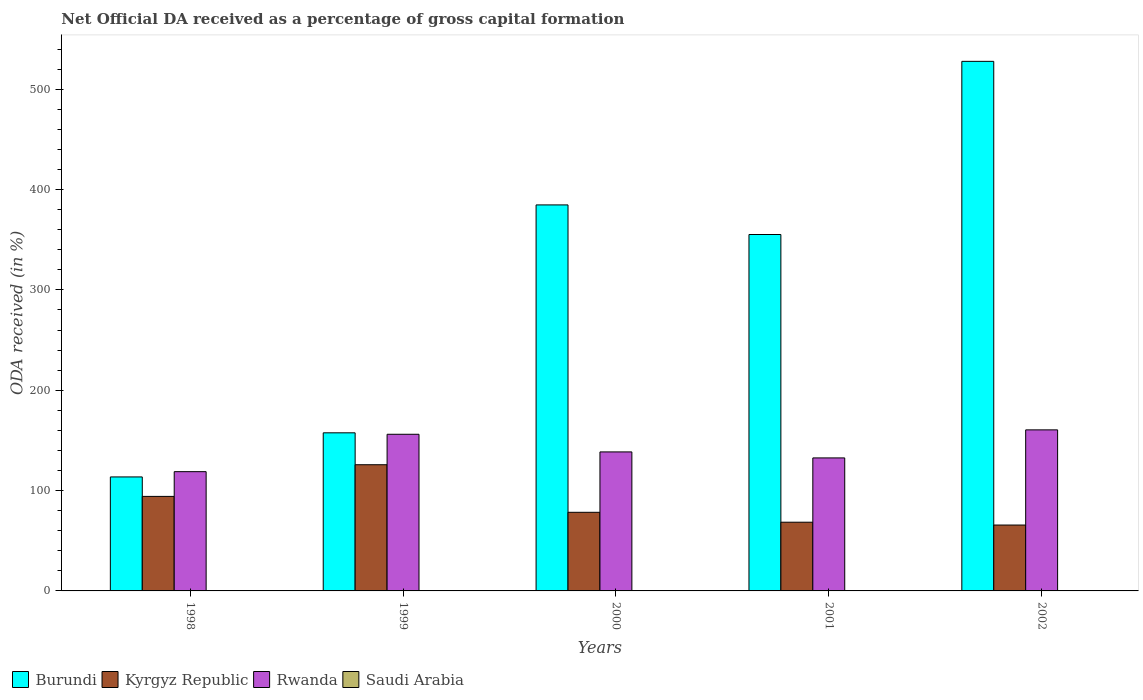Are the number of bars per tick equal to the number of legend labels?
Your answer should be very brief. Yes. How many bars are there on the 2nd tick from the right?
Your answer should be very brief. 4. What is the net ODA received in Kyrgyz Republic in 2000?
Make the answer very short. 78.34. Across all years, what is the maximum net ODA received in Burundi?
Your response must be concise. 527.71. Across all years, what is the minimum net ODA received in Kyrgyz Republic?
Ensure brevity in your answer.  65.66. What is the total net ODA received in Rwanda in the graph?
Give a very brief answer. 706.49. What is the difference between the net ODA received in Burundi in 1998 and that in 2000?
Ensure brevity in your answer.  -271.05. What is the difference between the net ODA received in Saudi Arabia in 2000 and the net ODA received in Rwanda in 2002?
Your response must be concise. -160.42. What is the average net ODA received in Kyrgyz Republic per year?
Your response must be concise. 86.48. In the year 2002, what is the difference between the net ODA received in Rwanda and net ODA received in Kyrgyz Republic?
Offer a very short reply. 94.83. In how many years, is the net ODA received in Burundi greater than 200 %?
Offer a terse response. 3. What is the ratio of the net ODA received in Burundi in 1998 to that in 2001?
Your response must be concise. 0.32. Is the net ODA received in Rwanda in 2000 less than that in 2001?
Your answer should be very brief. No. What is the difference between the highest and the second highest net ODA received in Saudi Arabia?
Your response must be concise. 0. What is the difference between the highest and the lowest net ODA received in Kyrgyz Republic?
Give a very brief answer. 60.09. In how many years, is the net ODA received in Saudi Arabia greater than the average net ODA received in Saudi Arabia taken over all years?
Offer a very short reply. 2. Is it the case that in every year, the sum of the net ODA received in Saudi Arabia and net ODA received in Rwanda is greater than the sum of net ODA received in Burundi and net ODA received in Kyrgyz Republic?
Keep it short and to the point. No. What does the 3rd bar from the left in 1999 represents?
Offer a terse response. Rwanda. What does the 2nd bar from the right in 1999 represents?
Your answer should be very brief. Rwanda. How many years are there in the graph?
Make the answer very short. 5. What is the title of the graph?
Your response must be concise. Net Official DA received as a percentage of gross capital formation. What is the label or title of the X-axis?
Provide a succinct answer. Years. What is the label or title of the Y-axis?
Offer a very short reply. ODA received (in %). What is the ODA received (in %) in Burundi in 1998?
Give a very brief answer. 113.59. What is the ODA received (in %) of Kyrgyz Republic in 1998?
Keep it short and to the point. 94.2. What is the ODA received (in %) in Rwanda in 1998?
Offer a very short reply. 118.84. What is the ODA received (in %) of Saudi Arabia in 1998?
Keep it short and to the point. 0.05. What is the ODA received (in %) of Burundi in 1999?
Your answer should be compact. 157.54. What is the ODA received (in %) in Kyrgyz Republic in 1999?
Ensure brevity in your answer.  125.75. What is the ODA received (in %) in Rwanda in 1999?
Offer a terse response. 156.1. What is the ODA received (in %) in Saudi Arabia in 1999?
Ensure brevity in your answer.  0.07. What is the ODA received (in %) in Burundi in 2000?
Give a very brief answer. 384.64. What is the ODA received (in %) in Kyrgyz Republic in 2000?
Provide a short and direct response. 78.34. What is the ODA received (in %) in Rwanda in 2000?
Provide a succinct answer. 138.52. What is the ODA received (in %) of Saudi Arabia in 2000?
Provide a succinct answer. 0.06. What is the ODA received (in %) of Burundi in 2001?
Your answer should be very brief. 355.15. What is the ODA received (in %) in Kyrgyz Republic in 2001?
Keep it short and to the point. 68.46. What is the ODA received (in %) in Rwanda in 2001?
Provide a short and direct response. 132.54. What is the ODA received (in %) in Saudi Arabia in 2001?
Your answer should be compact. 0.04. What is the ODA received (in %) of Burundi in 2002?
Provide a succinct answer. 527.71. What is the ODA received (in %) of Kyrgyz Republic in 2002?
Your answer should be compact. 65.66. What is the ODA received (in %) of Rwanda in 2002?
Your response must be concise. 160.48. What is the ODA received (in %) in Saudi Arabia in 2002?
Ensure brevity in your answer.  0.05. Across all years, what is the maximum ODA received (in %) of Burundi?
Make the answer very short. 527.71. Across all years, what is the maximum ODA received (in %) of Kyrgyz Republic?
Provide a succinct answer. 125.75. Across all years, what is the maximum ODA received (in %) in Rwanda?
Provide a short and direct response. 160.48. Across all years, what is the maximum ODA received (in %) in Saudi Arabia?
Ensure brevity in your answer.  0.07. Across all years, what is the minimum ODA received (in %) of Burundi?
Provide a short and direct response. 113.59. Across all years, what is the minimum ODA received (in %) of Kyrgyz Republic?
Your answer should be very brief. 65.66. Across all years, what is the minimum ODA received (in %) in Rwanda?
Your answer should be compact. 118.84. Across all years, what is the minimum ODA received (in %) of Saudi Arabia?
Your answer should be very brief. 0.04. What is the total ODA received (in %) of Burundi in the graph?
Your answer should be very brief. 1538.64. What is the total ODA received (in %) of Kyrgyz Republic in the graph?
Keep it short and to the point. 432.4. What is the total ODA received (in %) in Rwanda in the graph?
Keep it short and to the point. 706.49. What is the total ODA received (in %) of Saudi Arabia in the graph?
Keep it short and to the point. 0.26. What is the difference between the ODA received (in %) of Burundi in 1998 and that in 1999?
Keep it short and to the point. -43.95. What is the difference between the ODA received (in %) of Kyrgyz Republic in 1998 and that in 1999?
Your answer should be very brief. -31.55. What is the difference between the ODA received (in %) of Rwanda in 1998 and that in 1999?
Your answer should be very brief. -37.26. What is the difference between the ODA received (in %) of Saudi Arabia in 1998 and that in 1999?
Your response must be concise. -0.01. What is the difference between the ODA received (in %) in Burundi in 1998 and that in 2000?
Give a very brief answer. -271.05. What is the difference between the ODA received (in %) in Kyrgyz Republic in 1998 and that in 2000?
Ensure brevity in your answer.  15.86. What is the difference between the ODA received (in %) in Rwanda in 1998 and that in 2000?
Make the answer very short. -19.68. What is the difference between the ODA received (in %) of Saudi Arabia in 1998 and that in 2000?
Offer a terse response. -0.01. What is the difference between the ODA received (in %) of Burundi in 1998 and that in 2001?
Keep it short and to the point. -241.56. What is the difference between the ODA received (in %) of Kyrgyz Republic in 1998 and that in 2001?
Your answer should be compact. 25.73. What is the difference between the ODA received (in %) in Rwanda in 1998 and that in 2001?
Offer a terse response. -13.7. What is the difference between the ODA received (in %) of Saudi Arabia in 1998 and that in 2001?
Keep it short and to the point. 0.01. What is the difference between the ODA received (in %) in Burundi in 1998 and that in 2002?
Offer a very short reply. -414.11. What is the difference between the ODA received (in %) in Kyrgyz Republic in 1998 and that in 2002?
Keep it short and to the point. 28.54. What is the difference between the ODA received (in %) of Rwanda in 1998 and that in 2002?
Provide a succinct answer. -41.64. What is the difference between the ODA received (in %) of Saudi Arabia in 1998 and that in 2002?
Keep it short and to the point. 0. What is the difference between the ODA received (in %) of Burundi in 1999 and that in 2000?
Offer a terse response. -227.1. What is the difference between the ODA received (in %) in Kyrgyz Republic in 1999 and that in 2000?
Your answer should be very brief. 47.41. What is the difference between the ODA received (in %) of Rwanda in 1999 and that in 2000?
Your response must be concise. 17.58. What is the difference between the ODA received (in %) in Saudi Arabia in 1999 and that in 2000?
Ensure brevity in your answer.  0. What is the difference between the ODA received (in %) in Burundi in 1999 and that in 2001?
Your answer should be compact. -197.61. What is the difference between the ODA received (in %) of Kyrgyz Republic in 1999 and that in 2001?
Your response must be concise. 57.28. What is the difference between the ODA received (in %) in Rwanda in 1999 and that in 2001?
Ensure brevity in your answer.  23.56. What is the difference between the ODA received (in %) of Saudi Arabia in 1999 and that in 2001?
Your response must be concise. 0.03. What is the difference between the ODA received (in %) in Burundi in 1999 and that in 2002?
Ensure brevity in your answer.  -370.16. What is the difference between the ODA received (in %) of Kyrgyz Republic in 1999 and that in 2002?
Give a very brief answer. 60.09. What is the difference between the ODA received (in %) in Rwanda in 1999 and that in 2002?
Make the answer very short. -4.38. What is the difference between the ODA received (in %) of Saudi Arabia in 1999 and that in 2002?
Your response must be concise. 0.02. What is the difference between the ODA received (in %) of Burundi in 2000 and that in 2001?
Provide a short and direct response. 29.49. What is the difference between the ODA received (in %) in Kyrgyz Republic in 2000 and that in 2001?
Your response must be concise. 9.88. What is the difference between the ODA received (in %) of Rwanda in 2000 and that in 2001?
Your answer should be very brief. 5.98. What is the difference between the ODA received (in %) of Saudi Arabia in 2000 and that in 2001?
Offer a terse response. 0.02. What is the difference between the ODA received (in %) of Burundi in 2000 and that in 2002?
Keep it short and to the point. -143.06. What is the difference between the ODA received (in %) in Kyrgyz Republic in 2000 and that in 2002?
Your answer should be very brief. 12.68. What is the difference between the ODA received (in %) in Rwanda in 2000 and that in 2002?
Give a very brief answer. -21.96. What is the difference between the ODA received (in %) in Saudi Arabia in 2000 and that in 2002?
Offer a very short reply. 0.02. What is the difference between the ODA received (in %) in Burundi in 2001 and that in 2002?
Make the answer very short. -172.55. What is the difference between the ODA received (in %) of Kyrgyz Republic in 2001 and that in 2002?
Make the answer very short. 2.81. What is the difference between the ODA received (in %) in Rwanda in 2001 and that in 2002?
Provide a short and direct response. -27.94. What is the difference between the ODA received (in %) of Saudi Arabia in 2001 and that in 2002?
Offer a very short reply. -0.01. What is the difference between the ODA received (in %) of Burundi in 1998 and the ODA received (in %) of Kyrgyz Republic in 1999?
Provide a short and direct response. -12.15. What is the difference between the ODA received (in %) of Burundi in 1998 and the ODA received (in %) of Rwanda in 1999?
Your answer should be very brief. -42.51. What is the difference between the ODA received (in %) of Burundi in 1998 and the ODA received (in %) of Saudi Arabia in 1999?
Your answer should be compact. 113.53. What is the difference between the ODA received (in %) in Kyrgyz Republic in 1998 and the ODA received (in %) in Rwanda in 1999?
Ensure brevity in your answer.  -61.91. What is the difference between the ODA received (in %) of Kyrgyz Republic in 1998 and the ODA received (in %) of Saudi Arabia in 1999?
Your answer should be very brief. 94.13. What is the difference between the ODA received (in %) in Rwanda in 1998 and the ODA received (in %) in Saudi Arabia in 1999?
Your response must be concise. 118.77. What is the difference between the ODA received (in %) in Burundi in 1998 and the ODA received (in %) in Kyrgyz Republic in 2000?
Provide a short and direct response. 35.25. What is the difference between the ODA received (in %) of Burundi in 1998 and the ODA received (in %) of Rwanda in 2000?
Make the answer very short. -24.93. What is the difference between the ODA received (in %) in Burundi in 1998 and the ODA received (in %) in Saudi Arabia in 2000?
Provide a short and direct response. 113.53. What is the difference between the ODA received (in %) of Kyrgyz Republic in 1998 and the ODA received (in %) of Rwanda in 2000?
Ensure brevity in your answer.  -44.33. What is the difference between the ODA received (in %) of Kyrgyz Republic in 1998 and the ODA received (in %) of Saudi Arabia in 2000?
Your response must be concise. 94.13. What is the difference between the ODA received (in %) of Rwanda in 1998 and the ODA received (in %) of Saudi Arabia in 2000?
Ensure brevity in your answer.  118.78. What is the difference between the ODA received (in %) of Burundi in 1998 and the ODA received (in %) of Kyrgyz Republic in 2001?
Ensure brevity in your answer.  45.13. What is the difference between the ODA received (in %) in Burundi in 1998 and the ODA received (in %) in Rwanda in 2001?
Keep it short and to the point. -18.95. What is the difference between the ODA received (in %) in Burundi in 1998 and the ODA received (in %) in Saudi Arabia in 2001?
Provide a short and direct response. 113.56. What is the difference between the ODA received (in %) in Kyrgyz Republic in 1998 and the ODA received (in %) in Rwanda in 2001?
Provide a short and direct response. -38.34. What is the difference between the ODA received (in %) in Kyrgyz Republic in 1998 and the ODA received (in %) in Saudi Arabia in 2001?
Your answer should be very brief. 94.16. What is the difference between the ODA received (in %) in Rwanda in 1998 and the ODA received (in %) in Saudi Arabia in 2001?
Make the answer very short. 118.8. What is the difference between the ODA received (in %) of Burundi in 1998 and the ODA received (in %) of Kyrgyz Republic in 2002?
Provide a short and direct response. 47.94. What is the difference between the ODA received (in %) of Burundi in 1998 and the ODA received (in %) of Rwanda in 2002?
Your answer should be compact. -46.89. What is the difference between the ODA received (in %) of Burundi in 1998 and the ODA received (in %) of Saudi Arabia in 2002?
Make the answer very short. 113.55. What is the difference between the ODA received (in %) in Kyrgyz Republic in 1998 and the ODA received (in %) in Rwanda in 2002?
Make the answer very short. -66.29. What is the difference between the ODA received (in %) in Kyrgyz Republic in 1998 and the ODA received (in %) in Saudi Arabia in 2002?
Your answer should be compact. 94.15. What is the difference between the ODA received (in %) in Rwanda in 1998 and the ODA received (in %) in Saudi Arabia in 2002?
Offer a terse response. 118.79. What is the difference between the ODA received (in %) of Burundi in 1999 and the ODA received (in %) of Kyrgyz Republic in 2000?
Your answer should be very brief. 79.2. What is the difference between the ODA received (in %) of Burundi in 1999 and the ODA received (in %) of Rwanda in 2000?
Keep it short and to the point. 19.02. What is the difference between the ODA received (in %) in Burundi in 1999 and the ODA received (in %) in Saudi Arabia in 2000?
Your answer should be compact. 157.48. What is the difference between the ODA received (in %) in Kyrgyz Republic in 1999 and the ODA received (in %) in Rwanda in 2000?
Offer a terse response. -12.77. What is the difference between the ODA received (in %) of Kyrgyz Republic in 1999 and the ODA received (in %) of Saudi Arabia in 2000?
Keep it short and to the point. 125.68. What is the difference between the ODA received (in %) in Rwanda in 1999 and the ODA received (in %) in Saudi Arabia in 2000?
Provide a succinct answer. 156.04. What is the difference between the ODA received (in %) in Burundi in 1999 and the ODA received (in %) in Kyrgyz Republic in 2001?
Provide a short and direct response. 89.08. What is the difference between the ODA received (in %) of Burundi in 1999 and the ODA received (in %) of Rwanda in 2001?
Provide a short and direct response. 25. What is the difference between the ODA received (in %) in Burundi in 1999 and the ODA received (in %) in Saudi Arabia in 2001?
Your answer should be very brief. 157.51. What is the difference between the ODA received (in %) in Kyrgyz Republic in 1999 and the ODA received (in %) in Rwanda in 2001?
Provide a short and direct response. -6.79. What is the difference between the ODA received (in %) in Kyrgyz Republic in 1999 and the ODA received (in %) in Saudi Arabia in 2001?
Offer a terse response. 125.71. What is the difference between the ODA received (in %) in Rwanda in 1999 and the ODA received (in %) in Saudi Arabia in 2001?
Give a very brief answer. 156.06. What is the difference between the ODA received (in %) of Burundi in 1999 and the ODA received (in %) of Kyrgyz Republic in 2002?
Make the answer very short. 91.89. What is the difference between the ODA received (in %) in Burundi in 1999 and the ODA received (in %) in Rwanda in 2002?
Your answer should be very brief. -2.94. What is the difference between the ODA received (in %) in Burundi in 1999 and the ODA received (in %) in Saudi Arabia in 2002?
Keep it short and to the point. 157.5. What is the difference between the ODA received (in %) of Kyrgyz Republic in 1999 and the ODA received (in %) of Rwanda in 2002?
Keep it short and to the point. -34.74. What is the difference between the ODA received (in %) in Kyrgyz Republic in 1999 and the ODA received (in %) in Saudi Arabia in 2002?
Provide a succinct answer. 125.7. What is the difference between the ODA received (in %) of Rwanda in 1999 and the ODA received (in %) of Saudi Arabia in 2002?
Your answer should be very brief. 156.05. What is the difference between the ODA received (in %) in Burundi in 2000 and the ODA received (in %) in Kyrgyz Republic in 2001?
Your answer should be very brief. 316.18. What is the difference between the ODA received (in %) in Burundi in 2000 and the ODA received (in %) in Rwanda in 2001?
Offer a very short reply. 252.1. What is the difference between the ODA received (in %) in Burundi in 2000 and the ODA received (in %) in Saudi Arabia in 2001?
Make the answer very short. 384.61. What is the difference between the ODA received (in %) in Kyrgyz Republic in 2000 and the ODA received (in %) in Rwanda in 2001?
Give a very brief answer. -54.2. What is the difference between the ODA received (in %) of Kyrgyz Republic in 2000 and the ODA received (in %) of Saudi Arabia in 2001?
Provide a succinct answer. 78.3. What is the difference between the ODA received (in %) in Rwanda in 2000 and the ODA received (in %) in Saudi Arabia in 2001?
Give a very brief answer. 138.48. What is the difference between the ODA received (in %) of Burundi in 2000 and the ODA received (in %) of Kyrgyz Republic in 2002?
Give a very brief answer. 318.99. What is the difference between the ODA received (in %) of Burundi in 2000 and the ODA received (in %) of Rwanda in 2002?
Keep it short and to the point. 224.16. What is the difference between the ODA received (in %) in Burundi in 2000 and the ODA received (in %) in Saudi Arabia in 2002?
Offer a very short reply. 384.6. What is the difference between the ODA received (in %) of Kyrgyz Republic in 2000 and the ODA received (in %) of Rwanda in 2002?
Your response must be concise. -82.14. What is the difference between the ODA received (in %) in Kyrgyz Republic in 2000 and the ODA received (in %) in Saudi Arabia in 2002?
Keep it short and to the point. 78.29. What is the difference between the ODA received (in %) in Rwanda in 2000 and the ODA received (in %) in Saudi Arabia in 2002?
Provide a short and direct response. 138.48. What is the difference between the ODA received (in %) of Burundi in 2001 and the ODA received (in %) of Kyrgyz Republic in 2002?
Provide a succinct answer. 289.5. What is the difference between the ODA received (in %) in Burundi in 2001 and the ODA received (in %) in Rwanda in 2002?
Your response must be concise. 194.67. What is the difference between the ODA received (in %) in Burundi in 2001 and the ODA received (in %) in Saudi Arabia in 2002?
Provide a short and direct response. 355.11. What is the difference between the ODA received (in %) of Kyrgyz Republic in 2001 and the ODA received (in %) of Rwanda in 2002?
Provide a succinct answer. -92.02. What is the difference between the ODA received (in %) in Kyrgyz Republic in 2001 and the ODA received (in %) in Saudi Arabia in 2002?
Provide a succinct answer. 68.42. What is the difference between the ODA received (in %) of Rwanda in 2001 and the ODA received (in %) of Saudi Arabia in 2002?
Offer a terse response. 132.49. What is the average ODA received (in %) in Burundi per year?
Give a very brief answer. 307.73. What is the average ODA received (in %) of Kyrgyz Republic per year?
Ensure brevity in your answer.  86.48. What is the average ODA received (in %) in Rwanda per year?
Keep it short and to the point. 141.3. What is the average ODA received (in %) of Saudi Arabia per year?
Ensure brevity in your answer.  0.05. In the year 1998, what is the difference between the ODA received (in %) of Burundi and ODA received (in %) of Kyrgyz Republic?
Your answer should be compact. 19.4. In the year 1998, what is the difference between the ODA received (in %) of Burundi and ODA received (in %) of Rwanda?
Offer a very short reply. -5.25. In the year 1998, what is the difference between the ODA received (in %) of Burundi and ODA received (in %) of Saudi Arabia?
Your answer should be very brief. 113.54. In the year 1998, what is the difference between the ODA received (in %) of Kyrgyz Republic and ODA received (in %) of Rwanda?
Offer a terse response. -24.64. In the year 1998, what is the difference between the ODA received (in %) of Kyrgyz Republic and ODA received (in %) of Saudi Arabia?
Make the answer very short. 94.15. In the year 1998, what is the difference between the ODA received (in %) in Rwanda and ODA received (in %) in Saudi Arabia?
Provide a succinct answer. 118.79. In the year 1999, what is the difference between the ODA received (in %) in Burundi and ODA received (in %) in Kyrgyz Republic?
Your response must be concise. 31.8. In the year 1999, what is the difference between the ODA received (in %) of Burundi and ODA received (in %) of Rwanda?
Provide a short and direct response. 1.44. In the year 1999, what is the difference between the ODA received (in %) of Burundi and ODA received (in %) of Saudi Arabia?
Ensure brevity in your answer.  157.48. In the year 1999, what is the difference between the ODA received (in %) of Kyrgyz Republic and ODA received (in %) of Rwanda?
Your answer should be compact. -30.35. In the year 1999, what is the difference between the ODA received (in %) of Kyrgyz Republic and ODA received (in %) of Saudi Arabia?
Provide a succinct answer. 125.68. In the year 1999, what is the difference between the ODA received (in %) in Rwanda and ODA received (in %) in Saudi Arabia?
Give a very brief answer. 156.04. In the year 2000, what is the difference between the ODA received (in %) in Burundi and ODA received (in %) in Kyrgyz Republic?
Ensure brevity in your answer.  306.3. In the year 2000, what is the difference between the ODA received (in %) in Burundi and ODA received (in %) in Rwanda?
Keep it short and to the point. 246.12. In the year 2000, what is the difference between the ODA received (in %) of Burundi and ODA received (in %) of Saudi Arabia?
Your response must be concise. 384.58. In the year 2000, what is the difference between the ODA received (in %) of Kyrgyz Republic and ODA received (in %) of Rwanda?
Your answer should be compact. -60.18. In the year 2000, what is the difference between the ODA received (in %) of Kyrgyz Republic and ODA received (in %) of Saudi Arabia?
Keep it short and to the point. 78.28. In the year 2000, what is the difference between the ODA received (in %) of Rwanda and ODA received (in %) of Saudi Arabia?
Keep it short and to the point. 138.46. In the year 2001, what is the difference between the ODA received (in %) of Burundi and ODA received (in %) of Kyrgyz Republic?
Keep it short and to the point. 286.69. In the year 2001, what is the difference between the ODA received (in %) in Burundi and ODA received (in %) in Rwanda?
Offer a very short reply. 222.61. In the year 2001, what is the difference between the ODA received (in %) in Burundi and ODA received (in %) in Saudi Arabia?
Your answer should be very brief. 355.12. In the year 2001, what is the difference between the ODA received (in %) of Kyrgyz Republic and ODA received (in %) of Rwanda?
Your answer should be compact. -64.08. In the year 2001, what is the difference between the ODA received (in %) of Kyrgyz Republic and ODA received (in %) of Saudi Arabia?
Your answer should be very brief. 68.43. In the year 2001, what is the difference between the ODA received (in %) in Rwanda and ODA received (in %) in Saudi Arabia?
Ensure brevity in your answer.  132.5. In the year 2002, what is the difference between the ODA received (in %) in Burundi and ODA received (in %) in Kyrgyz Republic?
Ensure brevity in your answer.  462.05. In the year 2002, what is the difference between the ODA received (in %) in Burundi and ODA received (in %) in Rwanda?
Your answer should be very brief. 367.22. In the year 2002, what is the difference between the ODA received (in %) in Burundi and ODA received (in %) in Saudi Arabia?
Provide a succinct answer. 527.66. In the year 2002, what is the difference between the ODA received (in %) in Kyrgyz Republic and ODA received (in %) in Rwanda?
Give a very brief answer. -94.83. In the year 2002, what is the difference between the ODA received (in %) in Kyrgyz Republic and ODA received (in %) in Saudi Arabia?
Ensure brevity in your answer.  65.61. In the year 2002, what is the difference between the ODA received (in %) in Rwanda and ODA received (in %) in Saudi Arabia?
Keep it short and to the point. 160.44. What is the ratio of the ODA received (in %) of Burundi in 1998 to that in 1999?
Offer a very short reply. 0.72. What is the ratio of the ODA received (in %) in Kyrgyz Republic in 1998 to that in 1999?
Your answer should be very brief. 0.75. What is the ratio of the ODA received (in %) of Rwanda in 1998 to that in 1999?
Your response must be concise. 0.76. What is the ratio of the ODA received (in %) in Saudi Arabia in 1998 to that in 1999?
Keep it short and to the point. 0.78. What is the ratio of the ODA received (in %) in Burundi in 1998 to that in 2000?
Ensure brevity in your answer.  0.3. What is the ratio of the ODA received (in %) in Kyrgyz Republic in 1998 to that in 2000?
Your answer should be compact. 1.2. What is the ratio of the ODA received (in %) in Rwanda in 1998 to that in 2000?
Keep it short and to the point. 0.86. What is the ratio of the ODA received (in %) of Saudi Arabia in 1998 to that in 2000?
Give a very brief answer. 0.82. What is the ratio of the ODA received (in %) in Burundi in 1998 to that in 2001?
Give a very brief answer. 0.32. What is the ratio of the ODA received (in %) of Kyrgyz Republic in 1998 to that in 2001?
Ensure brevity in your answer.  1.38. What is the ratio of the ODA received (in %) of Rwanda in 1998 to that in 2001?
Make the answer very short. 0.9. What is the ratio of the ODA received (in %) in Saudi Arabia in 1998 to that in 2001?
Your answer should be compact. 1.34. What is the ratio of the ODA received (in %) of Burundi in 1998 to that in 2002?
Give a very brief answer. 0.22. What is the ratio of the ODA received (in %) in Kyrgyz Republic in 1998 to that in 2002?
Provide a succinct answer. 1.43. What is the ratio of the ODA received (in %) in Rwanda in 1998 to that in 2002?
Ensure brevity in your answer.  0.74. What is the ratio of the ODA received (in %) of Saudi Arabia in 1998 to that in 2002?
Provide a succinct answer. 1.1. What is the ratio of the ODA received (in %) of Burundi in 1999 to that in 2000?
Provide a succinct answer. 0.41. What is the ratio of the ODA received (in %) in Kyrgyz Republic in 1999 to that in 2000?
Ensure brevity in your answer.  1.61. What is the ratio of the ODA received (in %) in Rwanda in 1999 to that in 2000?
Ensure brevity in your answer.  1.13. What is the ratio of the ODA received (in %) of Saudi Arabia in 1999 to that in 2000?
Give a very brief answer. 1.05. What is the ratio of the ODA received (in %) in Burundi in 1999 to that in 2001?
Give a very brief answer. 0.44. What is the ratio of the ODA received (in %) of Kyrgyz Republic in 1999 to that in 2001?
Keep it short and to the point. 1.84. What is the ratio of the ODA received (in %) of Rwanda in 1999 to that in 2001?
Your response must be concise. 1.18. What is the ratio of the ODA received (in %) in Saudi Arabia in 1999 to that in 2001?
Your response must be concise. 1.72. What is the ratio of the ODA received (in %) in Burundi in 1999 to that in 2002?
Provide a short and direct response. 0.3. What is the ratio of the ODA received (in %) of Kyrgyz Republic in 1999 to that in 2002?
Make the answer very short. 1.92. What is the ratio of the ODA received (in %) of Rwanda in 1999 to that in 2002?
Offer a terse response. 0.97. What is the ratio of the ODA received (in %) in Saudi Arabia in 1999 to that in 2002?
Offer a very short reply. 1.41. What is the ratio of the ODA received (in %) of Burundi in 2000 to that in 2001?
Keep it short and to the point. 1.08. What is the ratio of the ODA received (in %) in Kyrgyz Republic in 2000 to that in 2001?
Keep it short and to the point. 1.14. What is the ratio of the ODA received (in %) in Rwanda in 2000 to that in 2001?
Give a very brief answer. 1.05. What is the ratio of the ODA received (in %) in Saudi Arabia in 2000 to that in 2001?
Your response must be concise. 1.64. What is the ratio of the ODA received (in %) in Burundi in 2000 to that in 2002?
Your response must be concise. 0.73. What is the ratio of the ODA received (in %) in Kyrgyz Republic in 2000 to that in 2002?
Give a very brief answer. 1.19. What is the ratio of the ODA received (in %) in Rwanda in 2000 to that in 2002?
Offer a very short reply. 0.86. What is the ratio of the ODA received (in %) of Saudi Arabia in 2000 to that in 2002?
Offer a very short reply. 1.35. What is the ratio of the ODA received (in %) in Burundi in 2001 to that in 2002?
Offer a very short reply. 0.67. What is the ratio of the ODA received (in %) in Kyrgyz Republic in 2001 to that in 2002?
Offer a terse response. 1.04. What is the ratio of the ODA received (in %) in Rwanda in 2001 to that in 2002?
Offer a very short reply. 0.83. What is the ratio of the ODA received (in %) of Saudi Arabia in 2001 to that in 2002?
Your answer should be very brief. 0.82. What is the difference between the highest and the second highest ODA received (in %) in Burundi?
Your response must be concise. 143.06. What is the difference between the highest and the second highest ODA received (in %) in Kyrgyz Republic?
Ensure brevity in your answer.  31.55. What is the difference between the highest and the second highest ODA received (in %) in Rwanda?
Offer a terse response. 4.38. What is the difference between the highest and the second highest ODA received (in %) of Saudi Arabia?
Give a very brief answer. 0. What is the difference between the highest and the lowest ODA received (in %) in Burundi?
Offer a very short reply. 414.11. What is the difference between the highest and the lowest ODA received (in %) of Kyrgyz Republic?
Provide a succinct answer. 60.09. What is the difference between the highest and the lowest ODA received (in %) of Rwanda?
Make the answer very short. 41.64. What is the difference between the highest and the lowest ODA received (in %) of Saudi Arabia?
Make the answer very short. 0.03. 